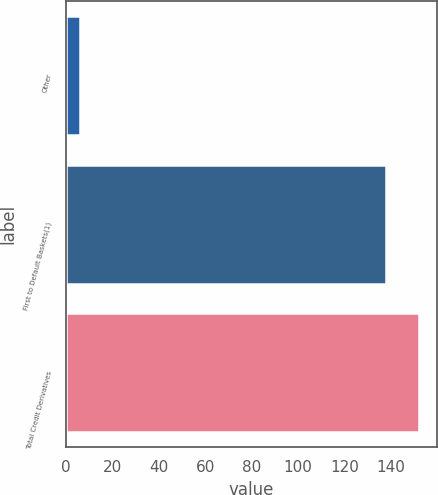<chart> <loc_0><loc_0><loc_500><loc_500><bar_chart><fcel>Other<fcel>First to Default Baskets(1)<fcel>Total Credit Derivatives<nl><fcel>6<fcel>138<fcel>152.2<nl></chart> 